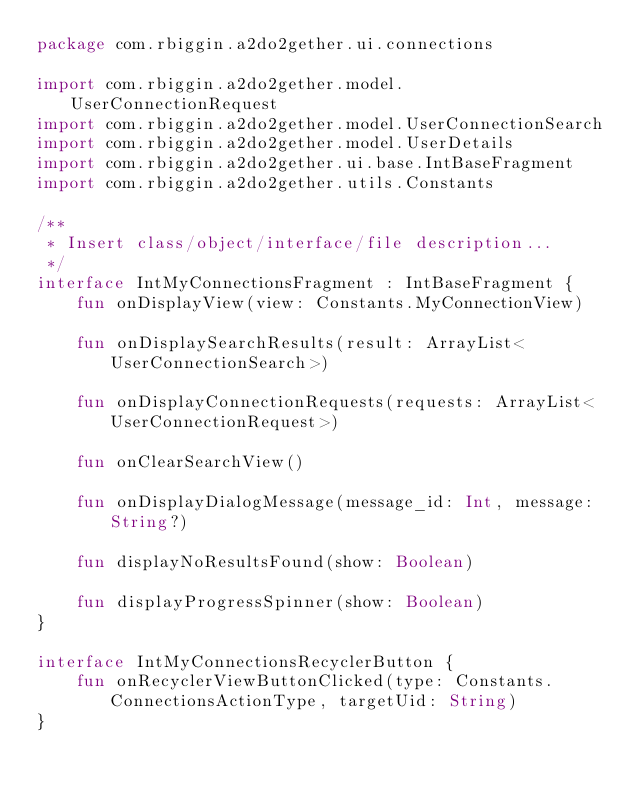Convert code to text. <code><loc_0><loc_0><loc_500><loc_500><_Kotlin_>package com.rbiggin.a2do2gether.ui.connections

import com.rbiggin.a2do2gether.model.UserConnectionRequest
import com.rbiggin.a2do2gether.model.UserConnectionSearch
import com.rbiggin.a2do2gether.model.UserDetails
import com.rbiggin.a2do2gether.ui.base.IntBaseFragment
import com.rbiggin.a2do2gether.utils.Constants

/**
 * Insert class/object/interface/file description...
 */
interface IntMyConnectionsFragment : IntBaseFragment {
    fun onDisplayView(view: Constants.MyConnectionView)

    fun onDisplaySearchResults(result: ArrayList<UserConnectionSearch>)

    fun onDisplayConnectionRequests(requests: ArrayList<UserConnectionRequest>)

    fun onClearSearchView()

    fun onDisplayDialogMessage(message_id: Int, message: String?)

    fun displayNoResultsFound(show: Boolean)

    fun displayProgressSpinner(show: Boolean)
}

interface IntMyConnectionsRecyclerButton {
    fun onRecyclerViewButtonClicked(type: Constants.ConnectionsActionType, targetUid: String)
}</code> 